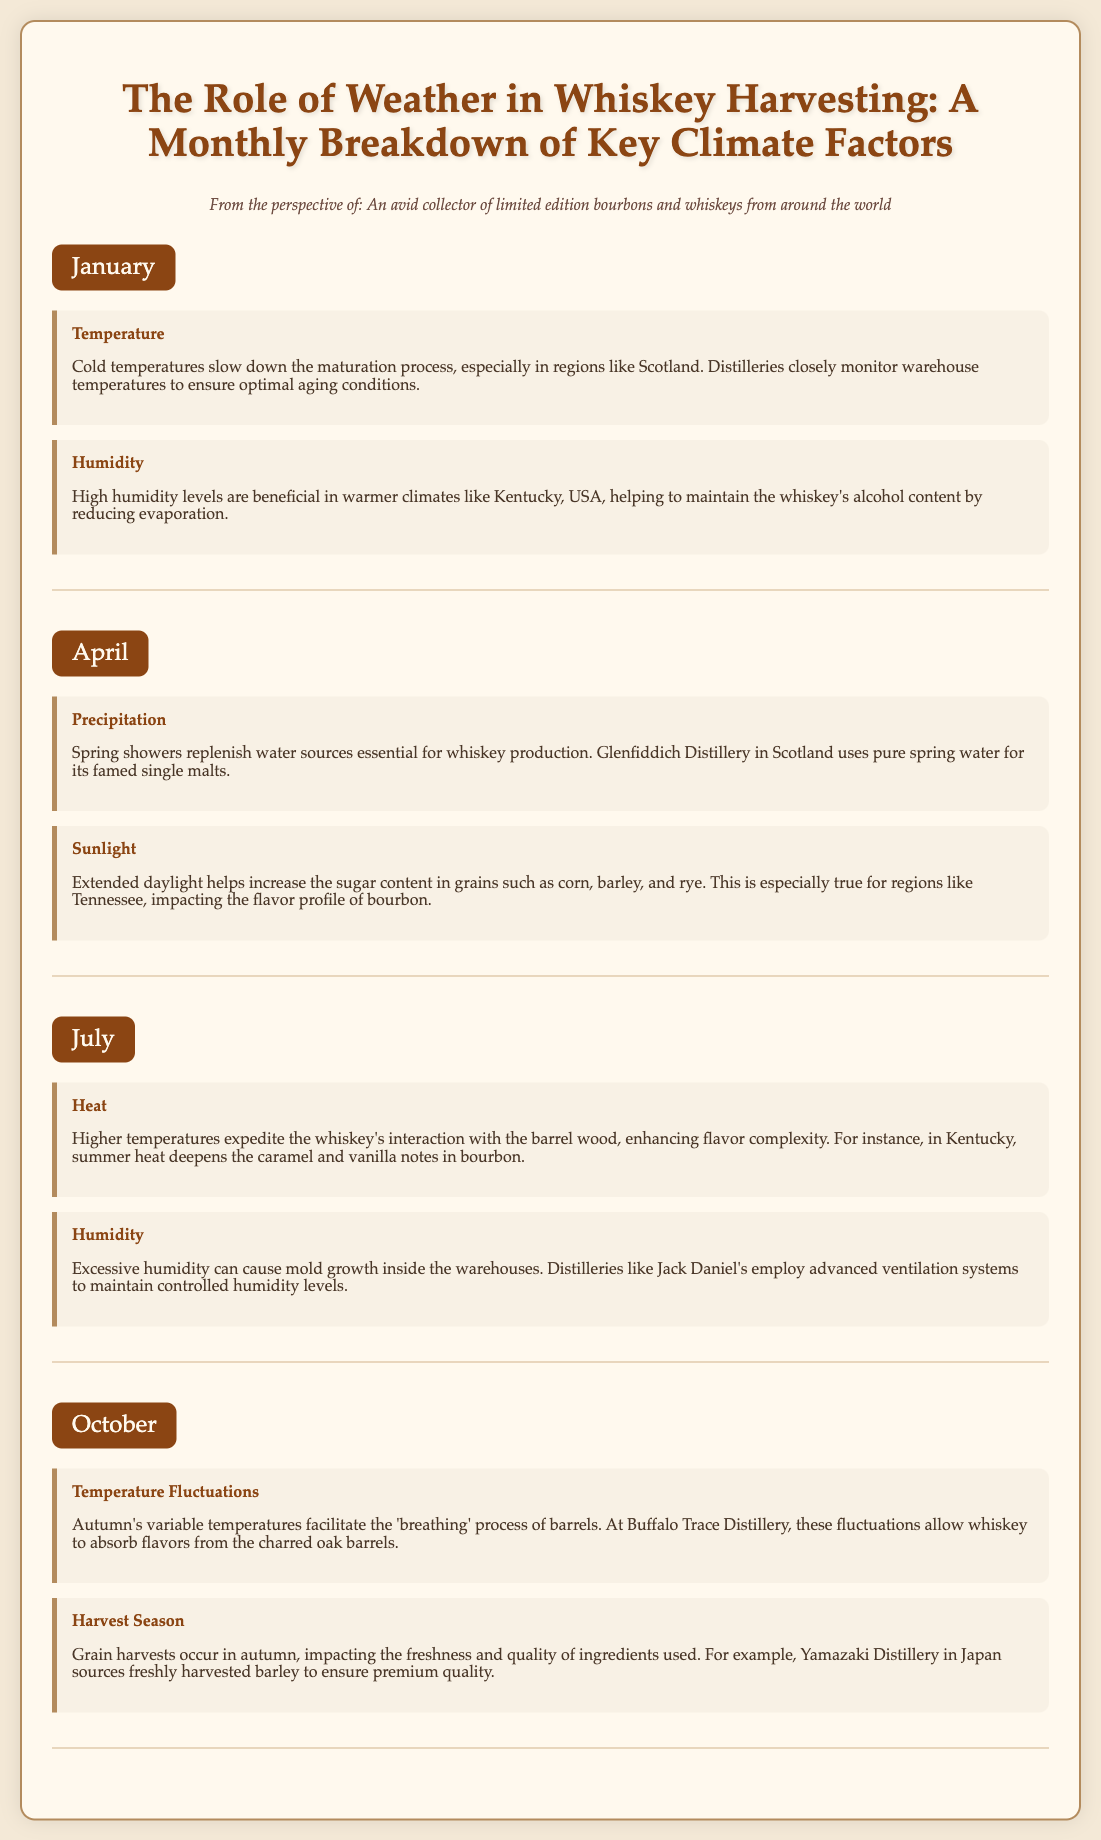What are the key climate factors affecting whiskey harvesting in January? The document mentions temperature and humidity as the key climate factors in January.
Answer: Temperature, Humidity How does humidity affect whiskey in warmer climates? The document states that high humidity levels help maintain the whiskey's alcohol content by reducing evaporation.
Answer: Maintain alcohol content What factor increases sugar content in grains during April? According to the document, sunlight helps increase the sugar content in grains such as corn, barley, and rye.
Answer: Sunlight What is the impact of heat on whiskey during July? The document explains that higher temperatures expedite the whiskey's interaction with the barrel wood, enhancing flavor complexity.
Answer: Enhances flavor complexity What significant process occurs in October related to barrels? The document indicates that autumn's variable temperatures facilitate the 'breathing' process of barrels.
Answer: Breathing process Which distillery uses pure spring water for its whiskey production? The document mentions Glenfiddich Distillery as the one that uses pure spring water for its famed single malts.
Answer: Glenfiddich Distillery What happens to whiskey flavors during hot summer months? The document states that summer heat deepens the caramel and vanilla notes in bourbon.
Answer: Deepens caramel and vanilla notes In which month is the grain harvest season mentioned? The document indicates that the grain harvest season occurs in October.
Answer: October How do distilleries manage excessive humidity during July? The document explains that distilleries like Jack Daniel's employ advanced ventilation systems to maintain controlled humidity levels.
Answer: Advanced ventilation systems 